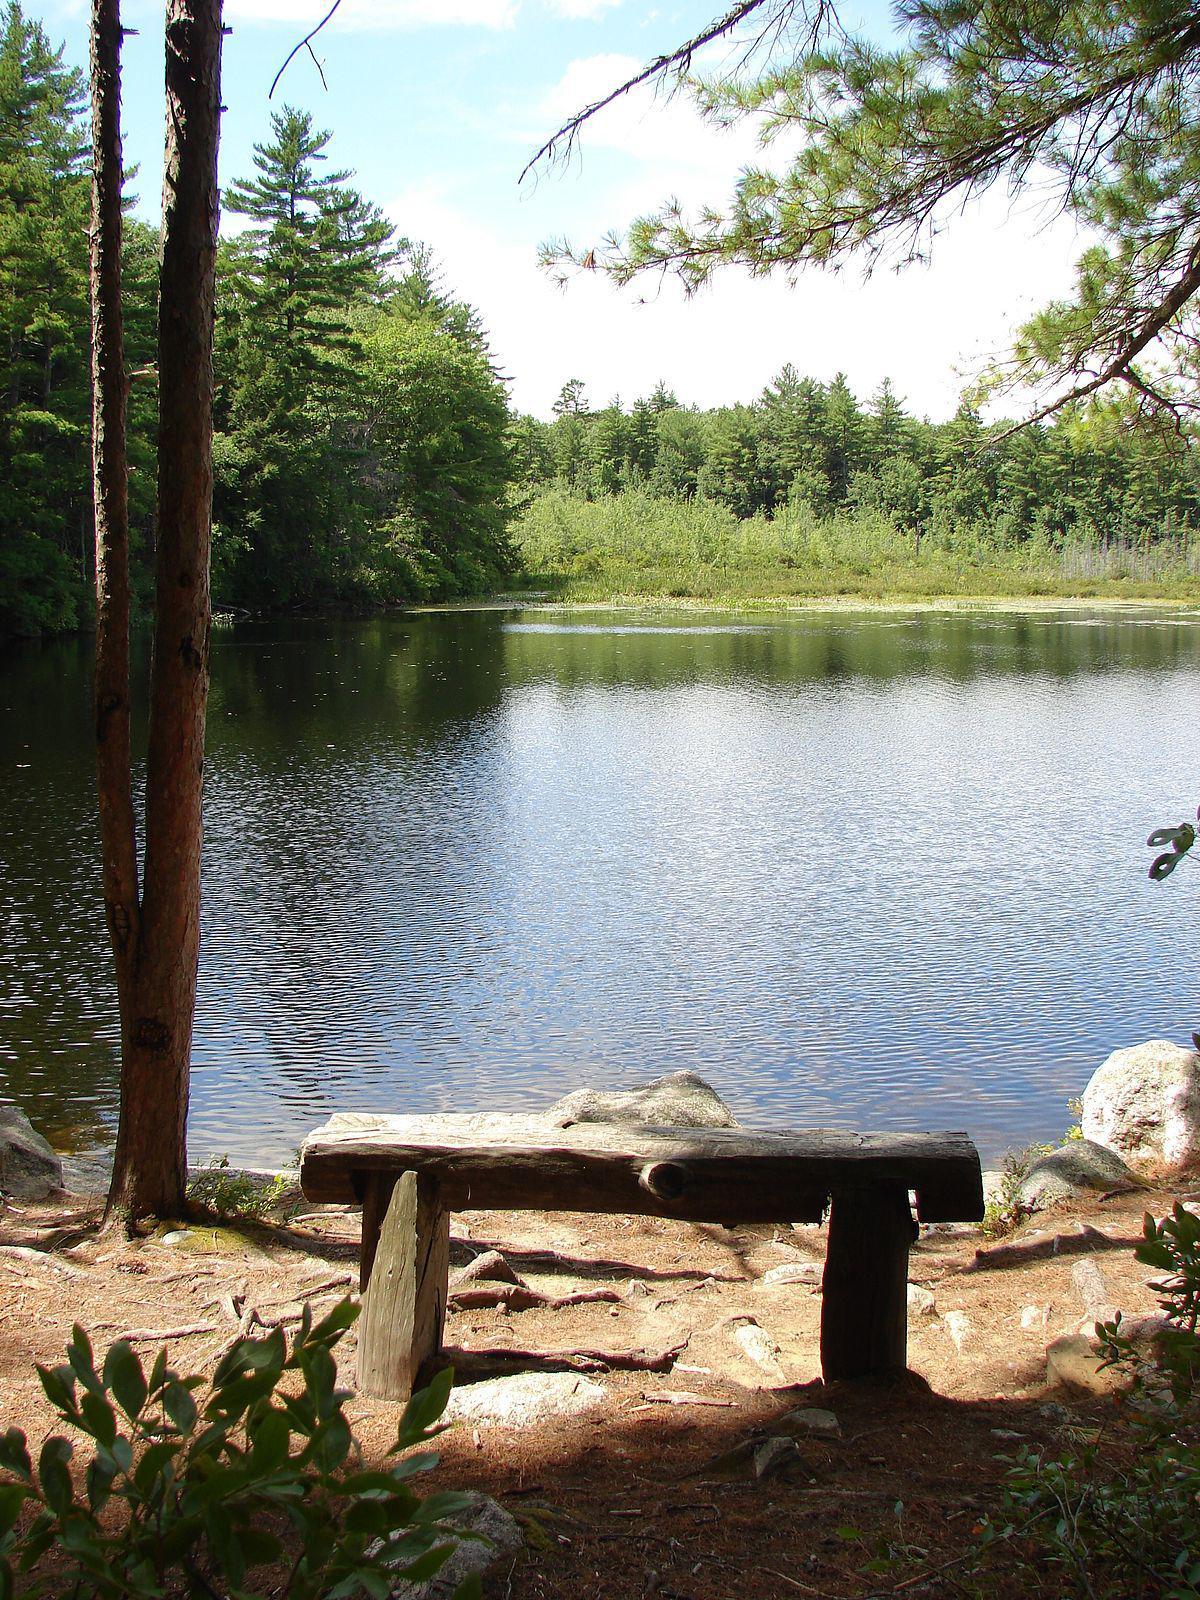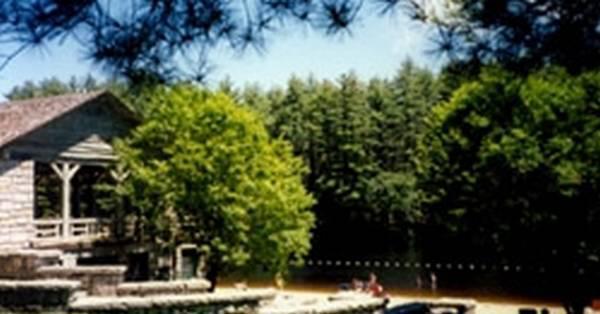The first image is the image on the left, the second image is the image on the right. For the images displayed, is the sentence "There is a two story event house nestled into the wood looking over a beach." factually correct? Answer yes or no. No. 